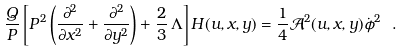<formula> <loc_0><loc_0><loc_500><loc_500>\frac { Q } { P } \left [ P ^ { 2 } \left ( \frac { \partial ^ { 2 } } { \partial x ^ { 2 } } + \frac { \partial ^ { 2 } } { \partial y ^ { 2 } } \right ) + \frac { 2 } { 3 } \, \Lambda \right ] H ( u , x , y ) = { \frac { 1 } { 4 } } \mathcal { A } ^ { 2 } ( u , x , y ) \dot { \phi } ^ { 2 } \ .</formula> 